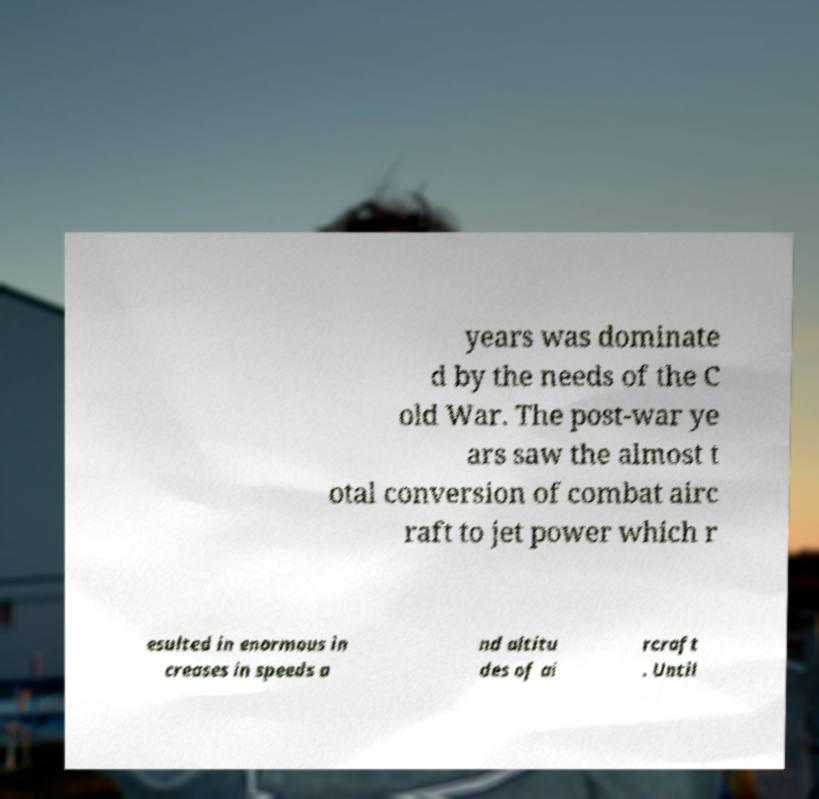Please read and relay the text visible in this image. What does it say? years was dominate d by the needs of the C old War. The post-war ye ars saw the almost t otal conversion of combat airc raft to jet power which r esulted in enormous in creases in speeds a nd altitu des of ai rcraft . Until 